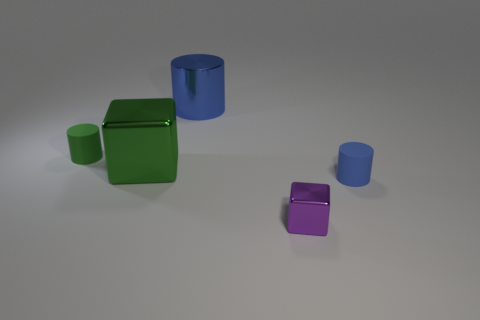Can you describe the arrangement of shapes seen in the image? Certainly! In the image, we see a collection of geometric solids arranged without a discernible pattern. There's a large green cube, lying slightly on its side, two blue cylinders of different sizes standing upright, and a small purple cube. The objects are placed on a flat surface, casting soft shadows, indicating a light source above them. 